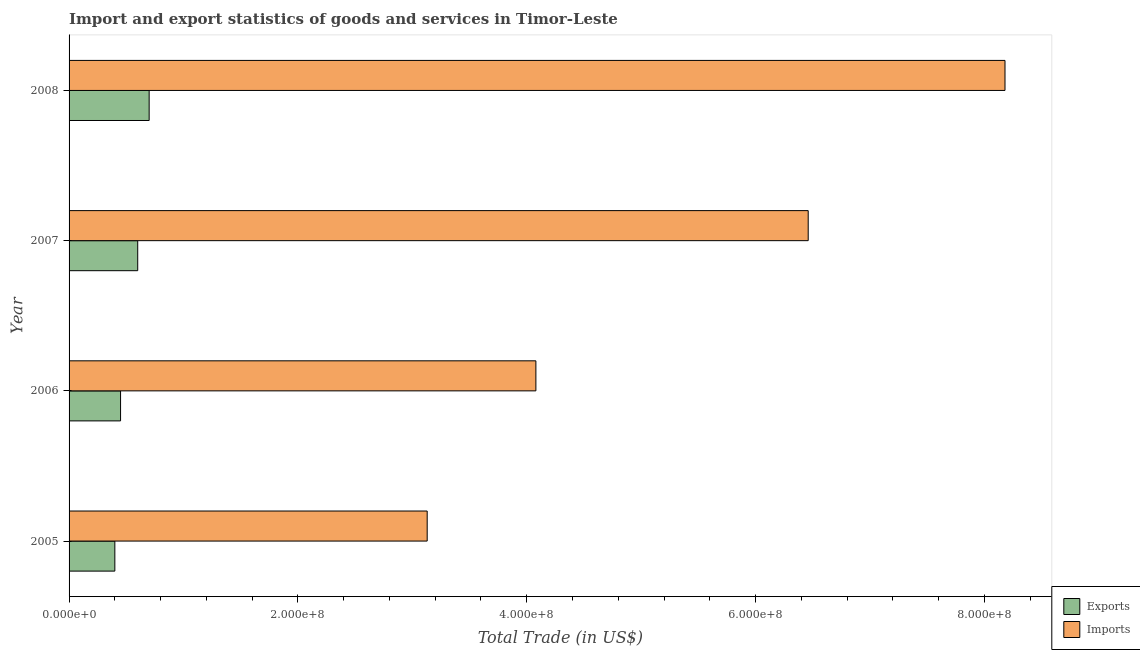How many different coloured bars are there?
Give a very brief answer. 2. How many groups of bars are there?
Provide a short and direct response. 4. How many bars are there on the 1st tick from the top?
Provide a short and direct response. 2. In how many cases, is the number of bars for a given year not equal to the number of legend labels?
Give a very brief answer. 0. What is the export of goods and services in 2008?
Provide a succinct answer. 7.00e+07. Across all years, what is the maximum export of goods and services?
Offer a very short reply. 7.00e+07. Across all years, what is the minimum export of goods and services?
Offer a terse response. 4.00e+07. In which year was the imports of goods and services minimum?
Your answer should be compact. 2005. What is the total export of goods and services in the graph?
Ensure brevity in your answer.  2.15e+08. What is the difference between the imports of goods and services in 2005 and that in 2006?
Your response must be concise. -9.50e+07. What is the difference between the imports of goods and services in 2008 and the export of goods and services in 2006?
Make the answer very short. 7.73e+08. What is the average export of goods and services per year?
Provide a succinct answer. 5.38e+07. In the year 2006, what is the difference between the imports of goods and services and export of goods and services?
Make the answer very short. 3.63e+08. What is the ratio of the export of goods and services in 2005 to that in 2006?
Give a very brief answer. 0.89. Is the export of goods and services in 2007 less than that in 2008?
Ensure brevity in your answer.  Yes. What is the difference between the highest and the second highest imports of goods and services?
Offer a very short reply. 1.72e+08. What is the difference between the highest and the lowest imports of goods and services?
Ensure brevity in your answer.  5.05e+08. In how many years, is the export of goods and services greater than the average export of goods and services taken over all years?
Offer a very short reply. 2. Is the sum of the export of goods and services in 2005 and 2007 greater than the maximum imports of goods and services across all years?
Keep it short and to the point. No. What does the 1st bar from the top in 2006 represents?
Your response must be concise. Imports. What does the 1st bar from the bottom in 2008 represents?
Provide a short and direct response. Exports. How many bars are there?
Ensure brevity in your answer.  8. Does the graph contain grids?
Give a very brief answer. No. Where does the legend appear in the graph?
Your answer should be compact. Bottom right. How many legend labels are there?
Offer a terse response. 2. How are the legend labels stacked?
Keep it short and to the point. Vertical. What is the title of the graph?
Ensure brevity in your answer.  Import and export statistics of goods and services in Timor-Leste. What is the label or title of the X-axis?
Your answer should be very brief. Total Trade (in US$). What is the Total Trade (in US$) of Exports in 2005?
Offer a terse response. 4.00e+07. What is the Total Trade (in US$) in Imports in 2005?
Provide a short and direct response. 3.13e+08. What is the Total Trade (in US$) in Exports in 2006?
Make the answer very short. 4.50e+07. What is the Total Trade (in US$) of Imports in 2006?
Offer a very short reply. 4.08e+08. What is the Total Trade (in US$) in Exports in 2007?
Offer a very short reply. 6.00e+07. What is the Total Trade (in US$) of Imports in 2007?
Offer a very short reply. 6.46e+08. What is the Total Trade (in US$) of Exports in 2008?
Ensure brevity in your answer.  7.00e+07. What is the Total Trade (in US$) of Imports in 2008?
Your response must be concise. 8.18e+08. Across all years, what is the maximum Total Trade (in US$) in Exports?
Give a very brief answer. 7.00e+07. Across all years, what is the maximum Total Trade (in US$) of Imports?
Offer a terse response. 8.18e+08. Across all years, what is the minimum Total Trade (in US$) in Exports?
Provide a short and direct response. 4.00e+07. Across all years, what is the minimum Total Trade (in US$) of Imports?
Offer a very short reply. 3.13e+08. What is the total Total Trade (in US$) of Exports in the graph?
Give a very brief answer. 2.15e+08. What is the total Total Trade (in US$) of Imports in the graph?
Your response must be concise. 2.18e+09. What is the difference between the Total Trade (in US$) of Exports in 2005 and that in 2006?
Provide a short and direct response. -5.00e+06. What is the difference between the Total Trade (in US$) in Imports in 2005 and that in 2006?
Give a very brief answer. -9.50e+07. What is the difference between the Total Trade (in US$) in Exports in 2005 and that in 2007?
Keep it short and to the point. -2.00e+07. What is the difference between the Total Trade (in US$) of Imports in 2005 and that in 2007?
Keep it short and to the point. -3.33e+08. What is the difference between the Total Trade (in US$) in Exports in 2005 and that in 2008?
Keep it short and to the point. -3.00e+07. What is the difference between the Total Trade (in US$) in Imports in 2005 and that in 2008?
Your response must be concise. -5.05e+08. What is the difference between the Total Trade (in US$) in Exports in 2006 and that in 2007?
Your answer should be very brief. -1.50e+07. What is the difference between the Total Trade (in US$) of Imports in 2006 and that in 2007?
Your answer should be very brief. -2.38e+08. What is the difference between the Total Trade (in US$) in Exports in 2006 and that in 2008?
Provide a succinct answer. -2.50e+07. What is the difference between the Total Trade (in US$) of Imports in 2006 and that in 2008?
Your response must be concise. -4.10e+08. What is the difference between the Total Trade (in US$) in Exports in 2007 and that in 2008?
Provide a succinct answer. -1.00e+07. What is the difference between the Total Trade (in US$) in Imports in 2007 and that in 2008?
Offer a terse response. -1.72e+08. What is the difference between the Total Trade (in US$) of Exports in 2005 and the Total Trade (in US$) of Imports in 2006?
Your response must be concise. -3.68e+08. What is the difference between the Total Trade (in US$) of Exports in 2005 and the Total Trade (in US$) of Imports in 2007?
Your answer should be compact. -6.06e+08. What is the difference between the Total Trade (in US$) in Exports in 2005 and the Total Trade (in US$) in Imports in 2008?
Your answer should be compact. -7.78e+08. What is the difference between the Total Trade (in US$) of Exports in 2006 and the Total Trade (in US$) of Imports in 2007?
Ensure brevity in your answer.  -6.01e+08. What is the difference between the Total Trade (in US$) in Exports in 2006 and the Total Trade (in US$) in Imports in 2008?
Offer a very short reply. -7.73e+08. What is the difference between the Total Trade (in US$) of Exports in 2007 and the Total Trade (in US$) of Imports in 2008?
Your answer should be compact. -7.58e+08. What is the average Total Trade (in US$) of Exports per year?
Make the answer very short. 5.38e+07. What is the average Total Trade (in US$) of Imports per year?
Your answer should be compact. 5.46e+08. In the year 2005, what is the difference between the Total Trade (in US$) in Exports and Total Trade (in US$) in Imports?
Your answer should be compact. -2.73e+08. In the year 2006, what is the difference between the Total Trade (in US$) of Exports and Total Trade (in US$) of Imports?
Provide a succinct answer. -3.63e+08. In the year 2007, what is the difference between the Total Trade (in US$) in Exports and Total Trade (in US$) in Imports?
Give a very brief answer. -5.86e+08. In the year 2008, what is the difference between the Total Trade (in US$) in Exports and Total Trade (in US$) in Imports?
Offer a terse response. -7.48e+08. What is the ratio of the Total Trade (in US$) of Exports in 2005 to that in 2006?
Offer a terse response. 0.89. What is the ratio of the Total Trade (in US$) in Imports in 2005 to that in 2006?
Your answer should be very brief. 0.77. What is the ratio of the Total Trade (in US$) in Exports in 2005 to that in 2007?
Ensure brevity in your answer.  0.67. What is the ratio of the Total Trade (in US$) of Imports in 2005 to that in 2007?
Ensure brevity in your answer.  0.48. What is the ratio of the Total Trade (in US$) in Imports in 2005 to that in 2008?
Ensure brevity in your answer.  0.38. What is the ratio of the Total Trade (in US$) of Exports in 2006 to that in 2007?
Give a very brief answer. 0.75. What is the ratio of the Total Trade (in US$) of Imports in 2006 to that in 2007?
Make the answer very short. 0.63. What is the ratio of the Total Trade (in US$) of Exports in 2006 to that in 2008?
Your answer should be compact. 0.64. What is the ratio of the Total Trade (in US$) of Imports in 2006 to that in 2008?
Ensure brevity in your answer.  0.5. What is the ratio of the Total Trade (in US$) in Imports in 2007 to that in 2008?
Your answer should be very brief. 0.79. What is the difference between the highest and the second highest Total Trade (in US$) of Imports?
Make the answer very short. 1.72e+08. What is the difference between the highest and the lowest Total Trade (in US$) in Exports?
Provide a succinct answer. 3.00e+07. What is the difference between the highest and the lowest Total Trade (in US$) in Imports?
Ensure brevity in your answer.  5.05e+08. 